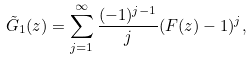<formula> <loc_0><loc_0><loc_500><loc_500>\tilde { G } _ { 1 } ( z ) = \sum _ { j = 1 } ^ { \infty } \frac { ( - 1 ) ^ { j - 1 } } { j } ( F ( z ) - 1 ) ^ { j } ,</formula> 